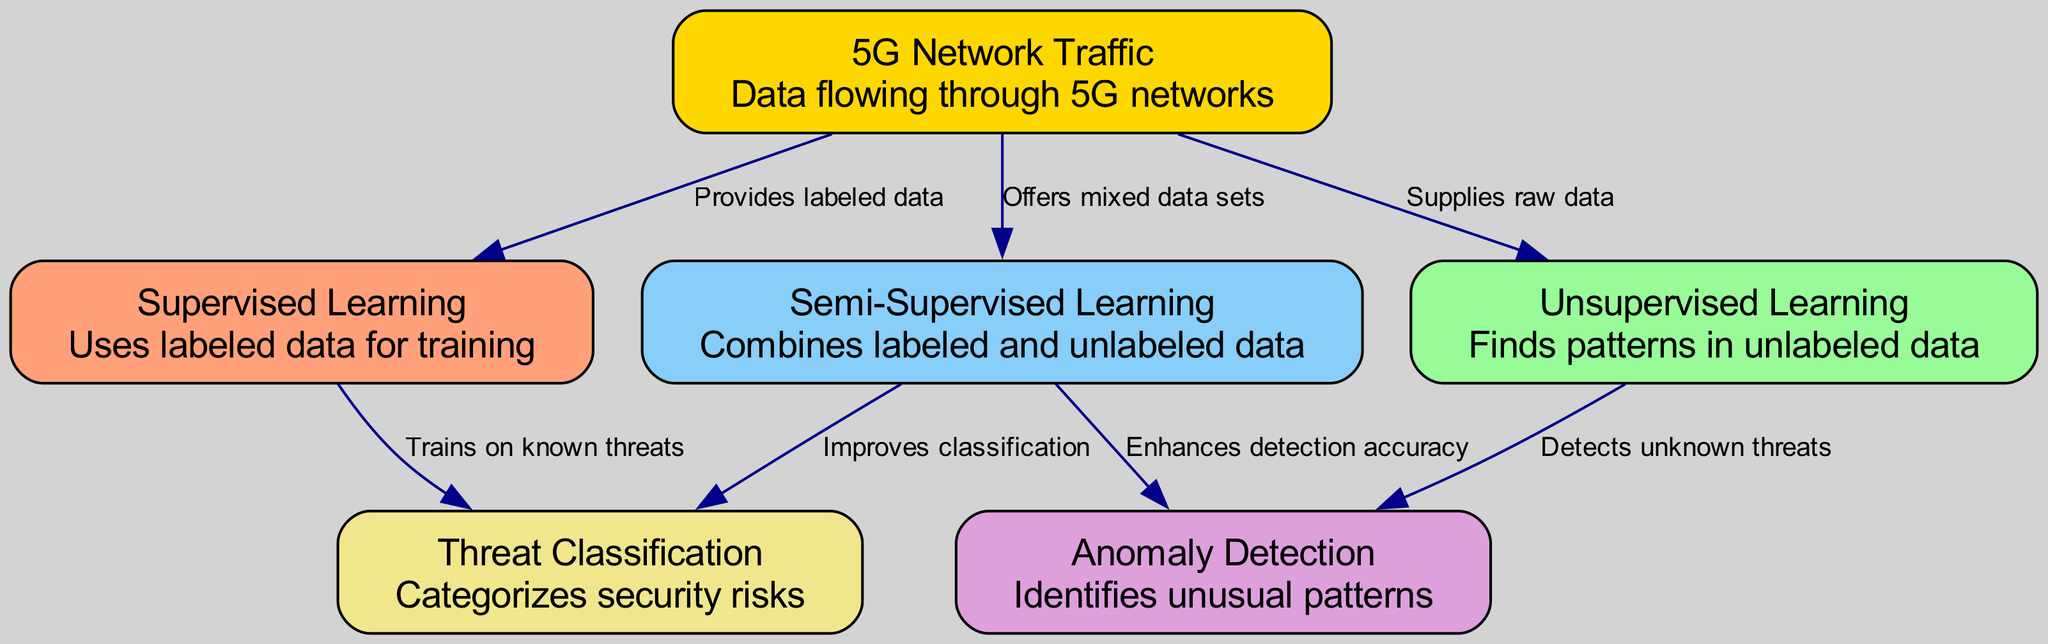What are the three learning techniques compared in the diagram? The diagram lists three nodes representing the learning techniques: Supervised Learning, Unsupervised Learning, and Semi-Supervised Learning.
Answer: Supervised Learning, Unsupervised Learning, Semi-Supervised Learning How many nodes are depicted in the diagram? By counting the nodes listed in the data, we see that there are six nodes represented: Supervised Learning, Unsupervised Learning, Semi-Supervised Learning, Anomaly Detection, Threat Classification, and 5G Network Traffic.
Answer: Six What does Supervised Learning train on? The edge connecting the Supervised Learning node to the Threat Classification node states that it "Trains on known threats." Therefore, Supervised Learning uses labeled data for training purposes.
Answer: Known threats Which technique is linked to both Anomaly Detection and Threat Classification? The Semi-Supervised Learning node connects to both Anomaly Detection and Threat Classification, indicating its role in enhancing detection accuracy and improving classification.
Answer: Semi-Supervised Learning What type of data does Unsupervised Learning utilize? According to the description of the Unsupervised Learning node, it is designed to find patterns in unlabeled data, which signifies its dependency on raw, unlabeled information for processing.
Answer: Unlabeled data Which learning technique improves classification according to the diagram? The diagram indicates that Semi-Supervised Learning is responsible for improving classification as it has a directed edge that points to the Threat Classification node with the label "Improves classification."
Answer: Semi-Supervised Learning What node provides labeled data to Supervised Learning? The 5G Network Traffic node has an edge that points to the Supervised Learning node, specifying that it "Provides labeled data,” which is essential for the training process in supervised learning.
Answer: 5G Network Traffic What does the Unsupervised Learning node detect? The edge from the Unsupervised Learning node to the Anomaly Detection node indicates that it detects unknown threats, implying its focus on identifying security risks without prior labeling.
Answer: Unknown threats 